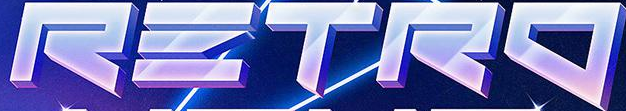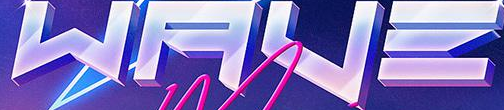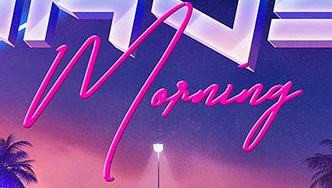Identify the words shown in these images in order, separated by a semicolon. RΞTRO; WAVΞ; Morning 